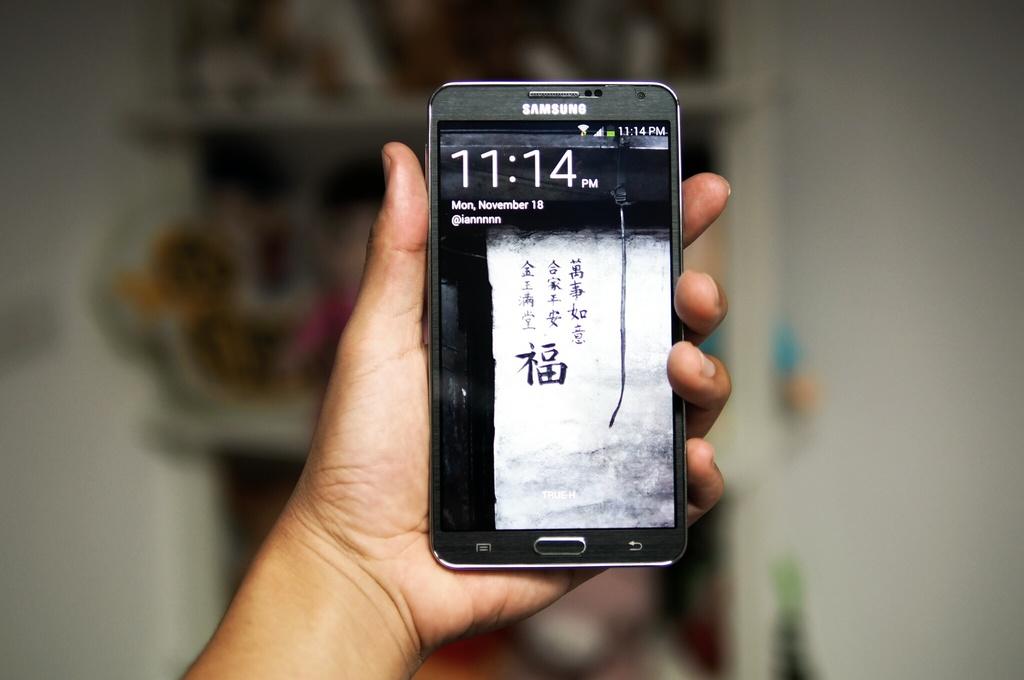What time is it?
Ensure brevity in your answer.  11:14. What time is shown on the phone?
Provide a succinct answer. 11:14 pm. 